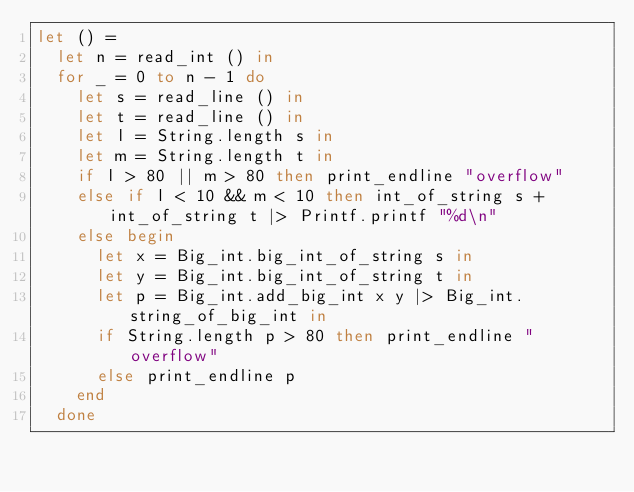<code> <loc_0><loc_0><loc_500><loc_500><_OCaml_>let () =
  let n = read_int () in
  for _ = 0 to n - 1 do
    let s = read_line () in
    let t = read_line () in
    let l = String.length s in
    let m = String.length t in
    if l > 80 || m > 80 then print_endline "overflow"
    else if l < 10 && m < 10 then int_of_string s + int_of_string t |> Printf.printf "%d\n"
    else begin
      let x = Big_int.big_int_of_string s in
      let y = Big_int.big_int_of_string t in
      let p = Big_int.add_big_int x y |> Big_int.string_of_big_int in
      if String.length p > 80 then print_endline "overflow"
      else print_endline p
    end
  done</code> 